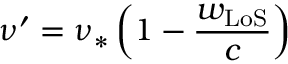Convert formula to latex. <formula><loc_0><loc_0><loc_500><loc_500>\nu ^ { \prime } = \nu _ { \ast } \left ( 1 - \frac { w _ { L o S } } { c } \right )</formula> 